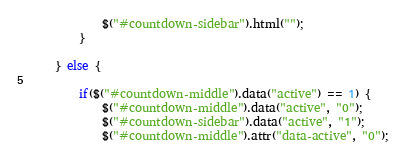Convert code to text. <code><loc_0><loc_0><loc_500><loc_500><_JavaScript_>            $("#countdown-sidebar").html("");
        }

    } else {

        if($("#countdown-middle").data("active") == 1) {
            $("#countdown-middle").data("active", "0");
            $("#countdown-sidebar").data("active", "1");
            $("#countdown-middle").attr("data-active", "0");</code> 